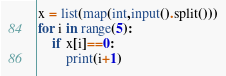<code> <loc_0><loc_0><loc_500><loc_500><_Python_>x = list(map(int,input().split()))
for i in range(5):
    if x[i]==0:
        print(i+1)</code> 